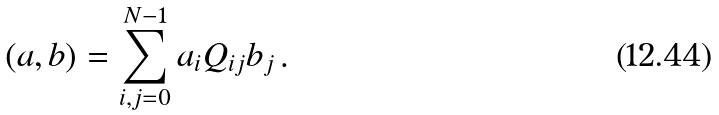<formula> <loc_0><loc_0><loc_500><loc_500>( a , b ) = \sum _ { i , j = 0 } ^ { N - 1 } a _ { i } Q _ { i j } b _ { j } \, .</formula> 